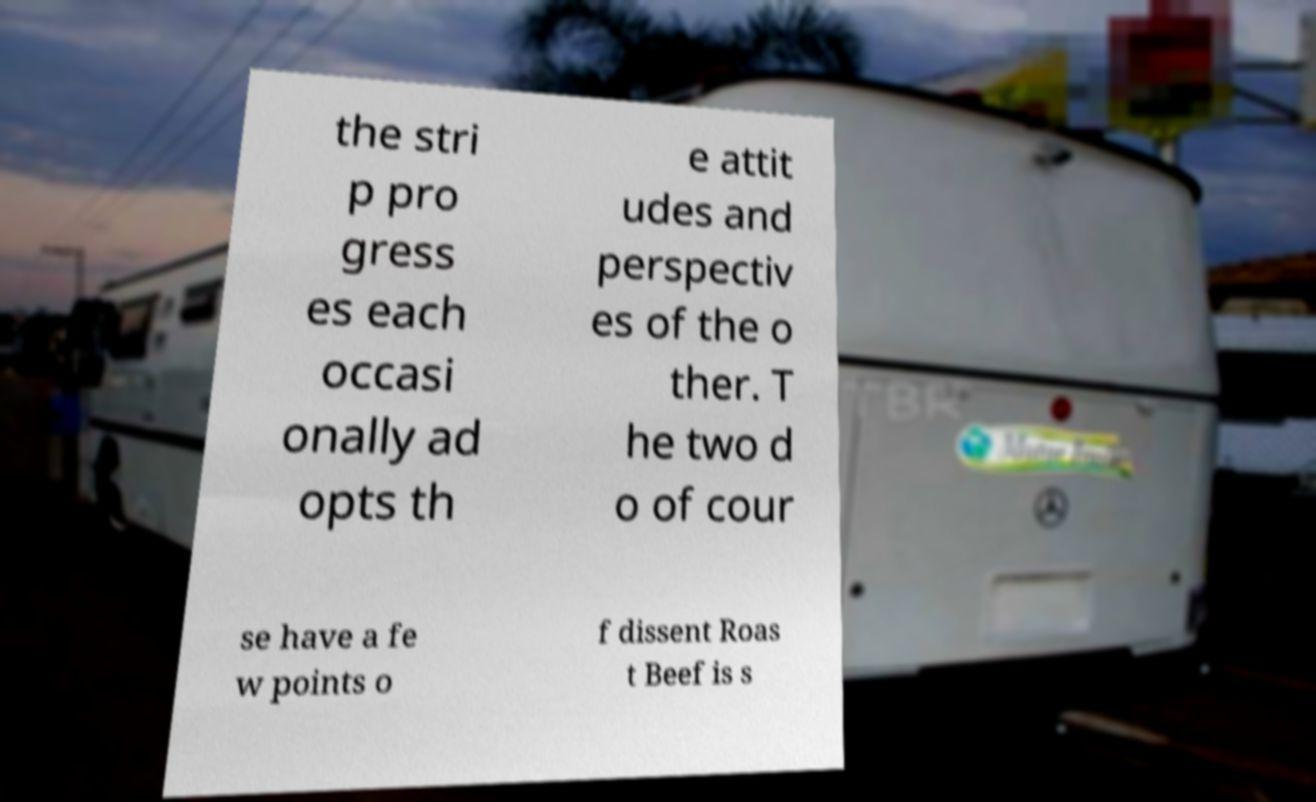What messages or text are displayed in this image? I need them in a readable, typed format. the stri p pro gress es each occasi onally ad opts th e attit udes and perspectiv es of the o ther. T he two d o of cour se have a fe w points o f dissent Roas t Beef is s 